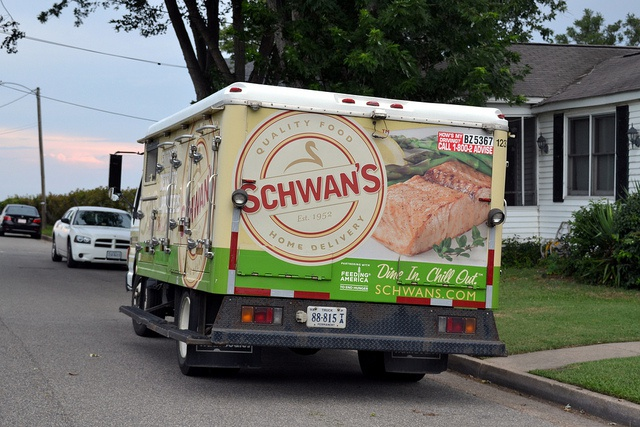Describe the objects in this image and their specific colors. I can see truck in darkgray, black, gray, and lightgray tones, car in darkgray, black, gray, and lightgray tones, and car in darkgray, black, and gray tones in this image. 